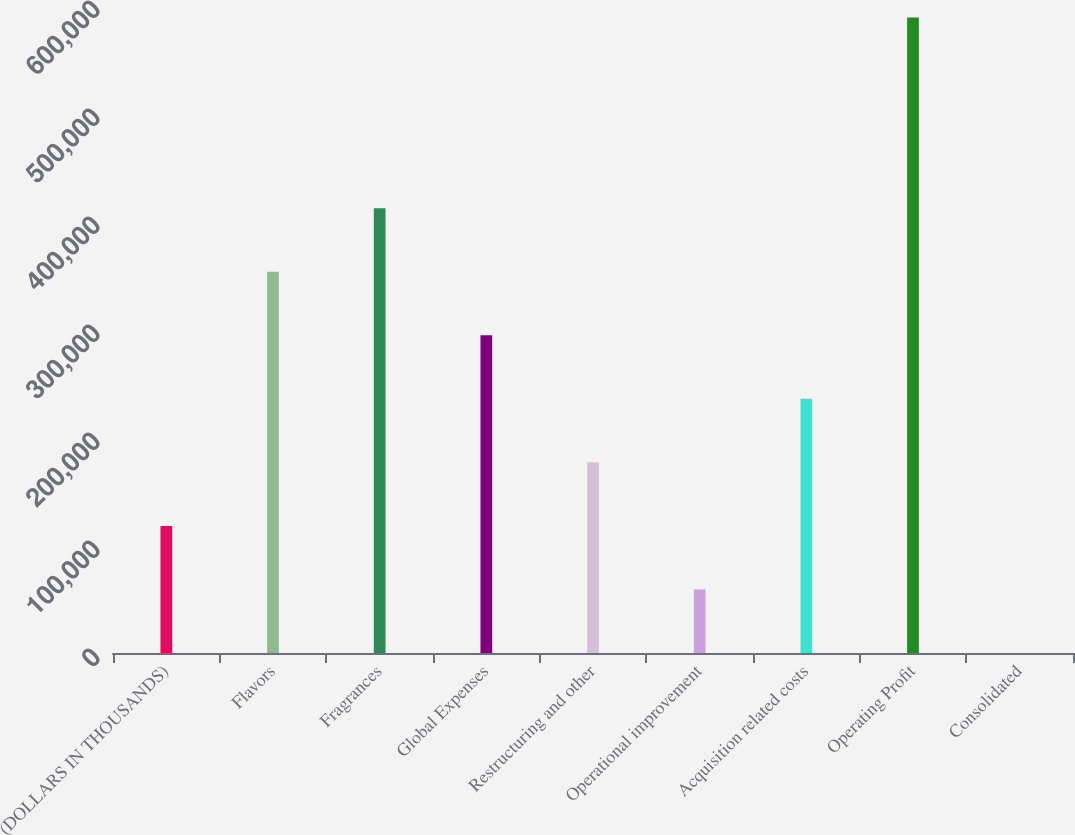Convert chart. <chart><loc_0><loc_0><loc_500><loc_500><bar_chart><fcel>(DOLLARS IN THOUSANDS)<fcel>Flavors<fcel>Fragrances<fcel>Global Expenses<fcel>Restructuring and other<fcel>Operational improvement<fcel>Acquisition related costs<fcel>Operating Profit<fcel>Consolidated<nl><fcel>117685<fcel>353016<fcel>411849<fcel>294183<fcel>176518<fcel>58852.2<fcel>235350<fcel>588347<fcel>19.5<nl></chart> 